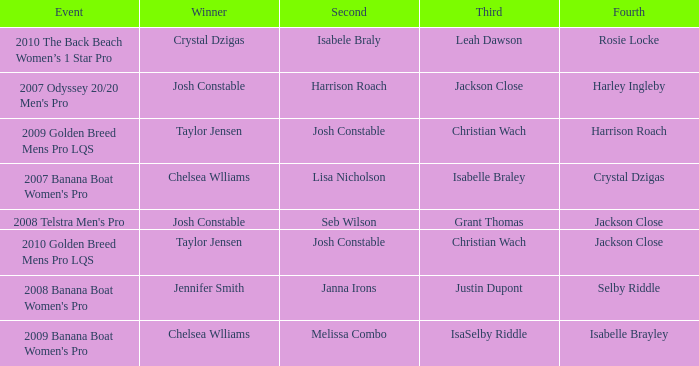Who was the Winner when Selby Riddle came in Fourth? Jennifer Smith. 